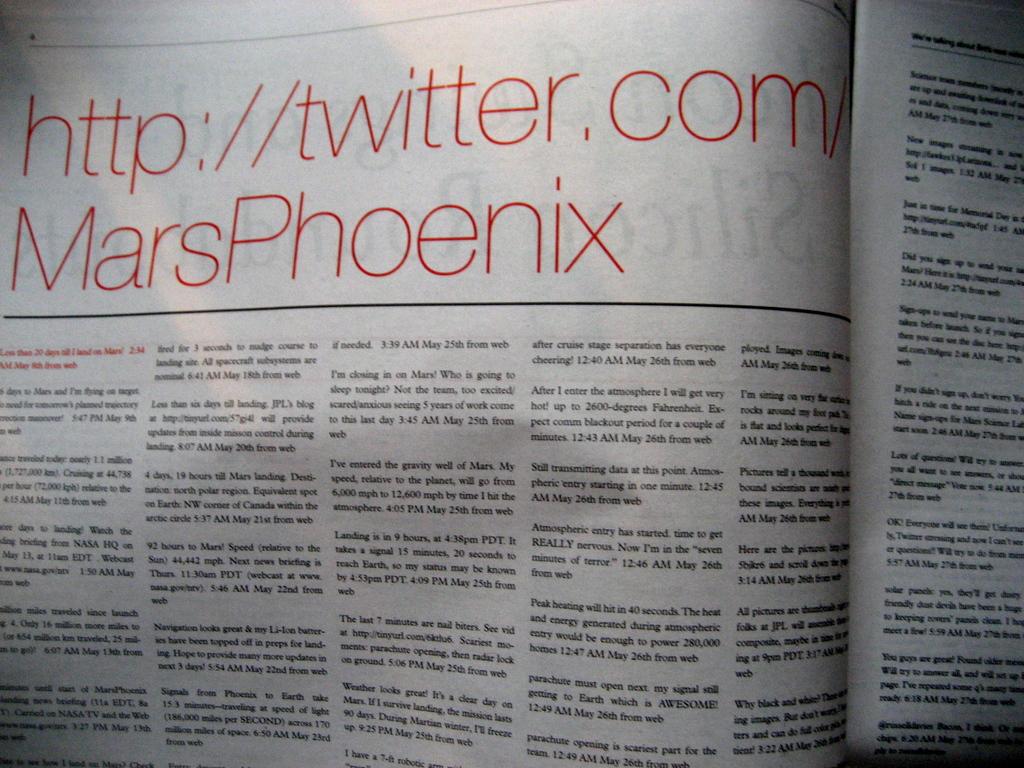What is the title?
Your answer should be very brief. Http://twitter.com/marsphoenix. What major website does the link send you to?
Provide a succinct answer. Twitter. 